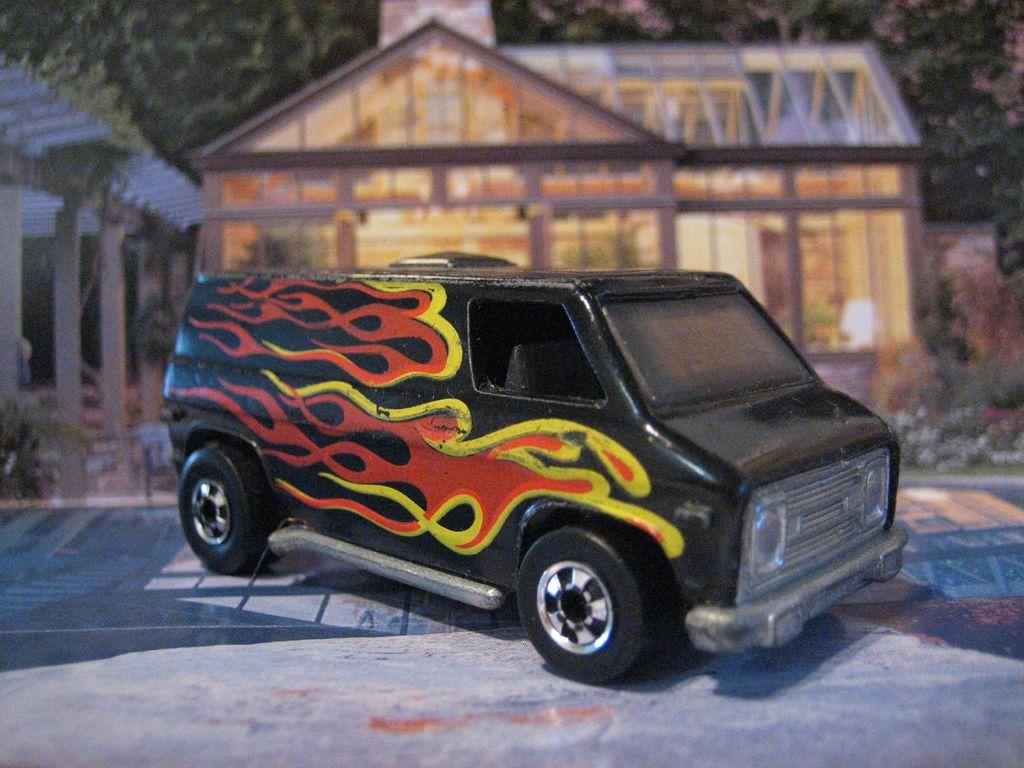What type of toy is in the image? There is a toy vehicle in black color in the image. What structure is present in the image? There is a wooden house with lights in the image. Where is the wooden house located in relation to the toy vehicle? The wooden house is behind the toy vehicle. What is on the left side of the image? There is a shed on the left side of the image. What can be seen at the top of the image? There are trees visible at the top of the image. What time of day is it in the image, as indicated by the presence of the afternoon sun? There is no mention of the sun or any indication of the time of day in the image. The presence of trees at the top of the image does not necessarily imply a specific time of day. 